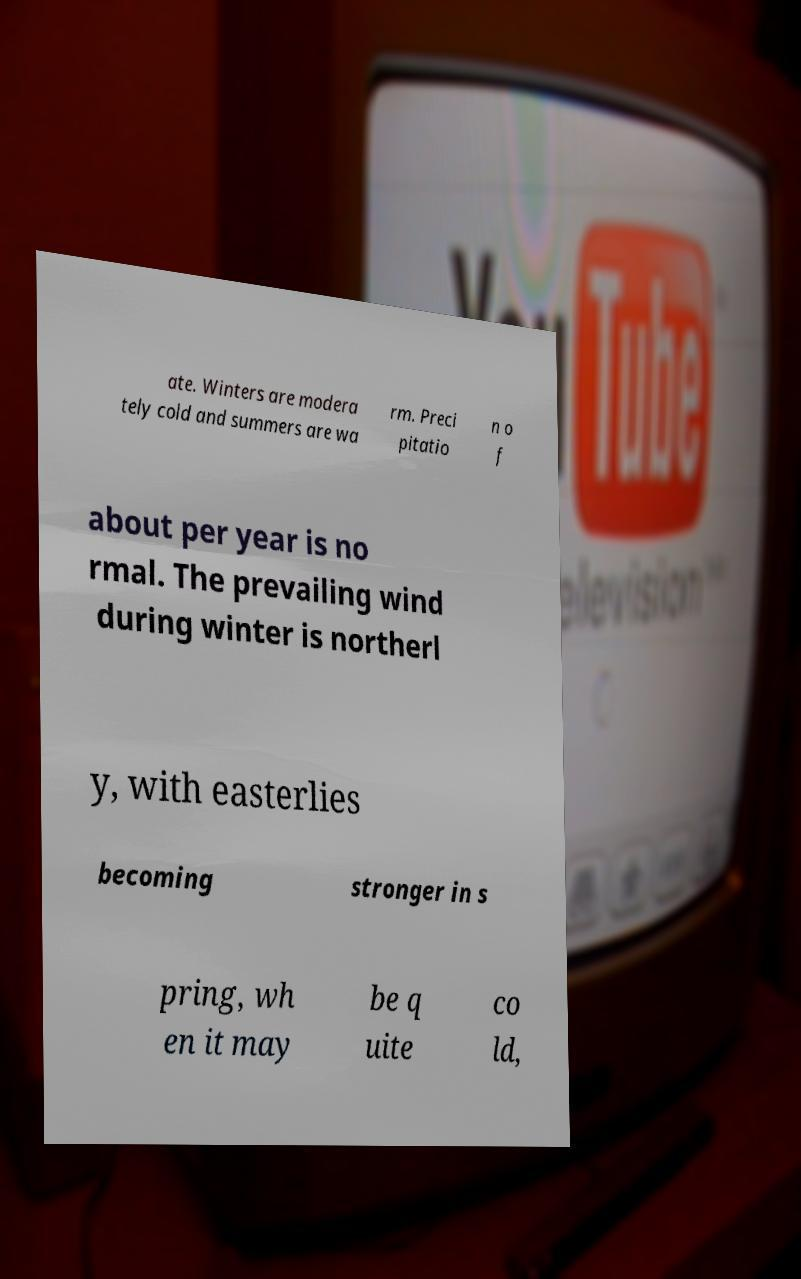There's text embedded in this image that I need extracted. Can you transcribe it verbatim? ate. Winters are modera tely cold and summers are wa rm. Preci pitatio n o f about per year is no rmal. The prevailing wind during winter is northerl y, with easterlies becoming stronger in s pring, wh en it may be q uite co ld, 